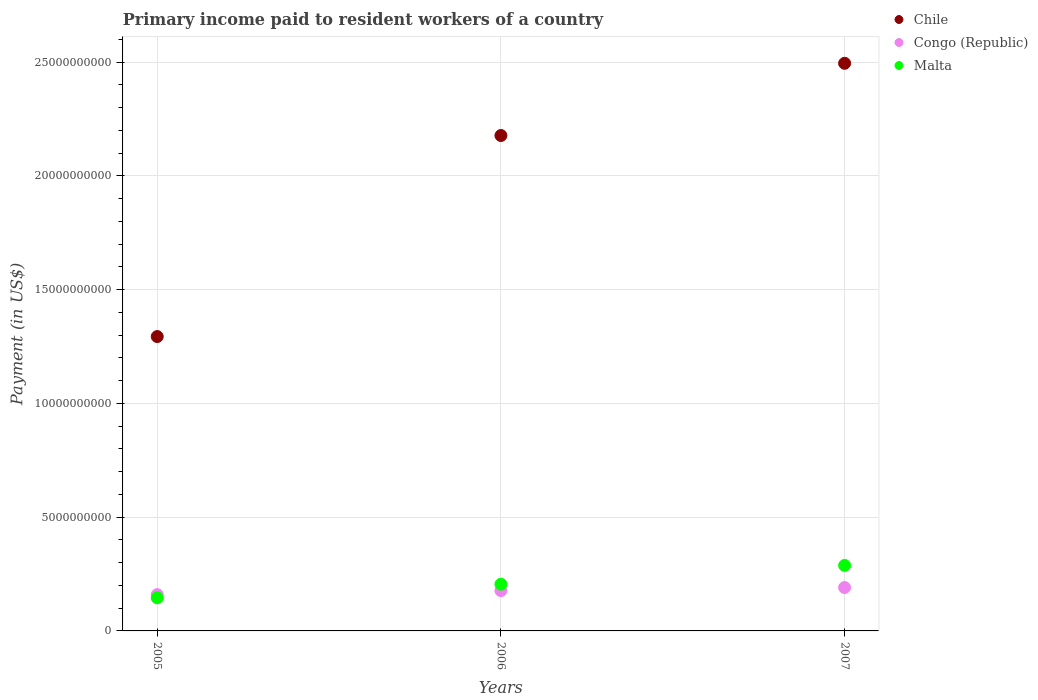Is the number of dotlines equal to the number of legend labels?
Your response must be concise. Yes. What is the amount paid to workers in Congo (Republic) in 2007?
Provide a short and direct response. 1.91e+09. Across all years, what is the maximum amount paid to workers in Malta?
Offer a terse response. 2.88e+09. Across all years, what is the minimum amount paid to workers in Chile?
Offer a terse response. 1.29e+1. In which year was the amount paid to workers in Congo (Republic) maximum?
Offer a terse response. 2007. In which year was the amount paid to workers in Congo (Republic) minimum?
Ensure brevity in your answer.  2005. What is the total amount paid to workers in Congo (Republic) in the graph?
Give a very brief answer. 5.28e+09. What is the difference between the amount paid to workers in Chile in 2006 and that in 2007?
Keep it short and to the point. -3.17e+09. What is the difference between the amount paid to workers in Chile in 2006 and the amount paid to workers in Malta in 2007?
Ensure brevity in your answer.  1.89e+1. What is the average amount paid to workers in Malta per year?
Make the answer very short. 2.13e+09. In the year 2005, what is the difference between the amount paid to workers in Chile and amount paid to workers in Congo (Republic)?
Offer a terse response. 1.13e+1. In how many years, is the amount paid to workers in Chile greater than 2000000000 US$?
Your response must be concise. 3. What is the ratio of the amount paid to workers in Chile in 2005 to that in 2006?
Provide a short and direct response. 0.59. Is the amount paid to workers in Congo (Republic) in 2005 less than that in 2006?
Make the answer very short. Yes. What is the difference between the highest and the second highest amount paid to workers in Chile?
Make the answer very short. 3.17e+09. What is the difference between the highest and the lowest amount paid to workers in Chile?
Ensure brevity in your answer.  1.20e+1. In how many years, is the amount paid to workers in Malta greater than the average amount paid to workers in Malta taken over all years?
Offer a terse response. 1. Is the sum of the amount paid to workers in Congo (Republic) in 2005 and 2006 greater than the maximum amount paid to workers in Chile across all years?
Your answer should be compact. No. Is it the case that in every year, the sum of the amount paid to workers in Chile and amount paid to workers in Malta  is greater than the amount paid to workers in Congo (Republic)?
Provide a short and direct response. Yes. Does the amount paid to workers in Congo (Republic) monotonically increase over the years?
Keep it short and to the point. Yes. Is the amount paid to workers in Chile strictly greater than the amount paid to workers in Congo (Republic) over the years?
Your response must be concise. Yes. How many years are there in the graph?
Your response must be concise. 3. What is the difference between two consecutive major ticks on the Y-axis?
Provide a short and direct response. 5.00e+09. Does the graph contain any zero values?
Offer a terse response. No. Where does the legend appear in the graph?
Provide a succinct answer. Top right. How many legend labels are there?
Your answer should be very brief. 3. What is the title of the graph?
Provide a short and direct response. Primary income paid to resident workers of a country. Does "Ukraine" appear as one of the legend labels in the graph?
Your answer should be compact. No. What is the label or title of the Y-axis?
Keep it short and to the point. Payment (in US$). What is the Payment (in US$) of Chile in 2005?
Provide a succinct answer. 1.29e+1. What is the Payment (in US$) of Congo (Republic) in 2005?
Ensure brevity in your answer.  1.60e+09. What is the Payment (in US$) of Malta in 2005?
Ensure brevity in your answer.  1.45e+09. What is the Payment (in US$) of Chile in 2006?
Provide a short and direct response. 2.18e+1. What is the Payment (in US$) of Congo (Republic) in 2006?
Give a very brief answer. 1.77e+09. What is the Payment (in US$) in Malta in 2006?
Your answer should be very brief. 2.05e+09. What is the Payment (in US$) in Chile in 2007?
Give a very brief answer. 2.49e+1. What is the Payment (in US$) of Congo (Republic) in 2007?
Ensure brevity in your answer.  1.91e+09. What is the Payment (in US$) in Malta in 2007?
Provide a succinct answer. 2.88e+09. Across all years, what is the maximum Payment (in US$) in Chile?
Ensure brevity in your answer.  2.49e+1. Across all years, what is the maximum Payment (in US$) in Congo (Republic)?
Your answer should be very brief. 1.91e+09. Across all years, what is the maximum Payment (in US$) in Malta?
Offer a very short reply. 2.88e+09. Across all years, what is the minimum Payment (in US$) in Chile?
Give a very brief answer. 1.29e+1. Across all years, what is the minimum Payment (in US$) of Congo (Republic)?
Keep it short and to the point. 1.60e+09. Across all years, what is the minimum Payment (in US$) in Malta?
Your response must be concise. 1.45e+09. What is the total Payment (in US$) of Chile in the graph?
Keep it short and to the point. 5.97e+1. What is the total Payment (in US$) of Congo (Republic) in the graph?
Give a very brief answer. 5.28e+09. What is the total Payment (in US$) in Malta in the graph?
Make the answer very short. 6.39e+09. What is the difference between the Payment (in US$) of Chile in 2005 and that in 2006?
Keep it short and to the point. -8.84e+09. What is the difference between the Payment (in US$) in Congo (Republic) in 2005 and that in 2006?
Your answer should be very brief. -1.77e+08. What is the difference between the Payment (in US$) of Malta in 2005 and that in 2006?
Your answer should be compact. -5.99e+08. What is the difference between the Payment (in US$) of Chile in 2005 and that in 2007?
Give a very brief answer. -1.20e+1. What is the difference between the Payment (in US$) of Congo (Republic) in 2005 and that in 2007?
Your response must be concise. -3.13e+08. What is the difference between the Payment (in US$) of Malta in 2005 and that in 2007?
Give a very brief answer. -1.42e+09. What is the difference between the Payment (in US$) of Chile in 2006 and that in 2007?
Your response must be concise. -3.17e+09. What is the difference between the Payment (in US$) in Congo (Republic) in 2006 and that in 2007?
Your answer should be very brief. -1.35e+08. What is the difference between the Payment (in US$) of Malta in 2006 and that in 2007?
Offer a terse response. -8.25e+08. What is the difference between the Payment (in US$) of Chile in 2005 and the Payment (in US$) of Congo (Republic) in 2006?
Offer a very short reply. 1.12e+1. What is the difference between the Payment (in US$) of Chile in 2005 and the Payment (in US$) of Malta in 2006?
Your answer should be compact. 1.09e+1. What is the difference between the Payment (in US$) in Congo (Republic) in 2005 and the Payment (in US$) in Malta in 2006?
Give a very brief answer. -4.58e+08. What is the difference between the Payment (in US$) of Chile in 2005 and the Payment (in US$) of Congo (Republic) in 2007?
Your answer should be very brief. 1.10e+1. What is the difference between the Payment (in US$) of Chile in 2005 and the Payment (in US$) of Malta in 2007?
Keep it short and to the point. 1.01e+1. What is the difference between the Payment (in US$) of Congo (Republic) in 2005 and the Payment (in US$) of Malta in 2007?
Keep it short and to the point. -1.28e+09. What is the difference between the Payment (in US$) in Chile in 2006 and the Payment (in US$) in Congo (Republic) in 2007?
Provide a short and direct response. 1.99e+1. What is the difference between the Payment (in US$) in Chile in 2006 and the Payment (in US$) in Malta in 2007?
Ensure brevity in your answer.  1.89e+1. What is the difference between the Payment (in US$) of Congo (Republic) in 2006 and the Payment (in US$) of Malta in 2007?
Keep it short and to the point. -1.11e+09. What is the average Payment (in US$) in Chile per year?
Offer a terse response. 1.99e+1. What is the average Payment (in US$) in Congo (Republic) per year?
Make the answer very short. 1.76e+09. What is the average Payment (in US$) of Malta per year?
Provide a short and direct response. 2.13e+09. In the year 2005, what is the difference between the Payment (in US$) of Chile and Payment (in US$) of Congo (Republic)?
Offer a very short reply. 1.13e+1. In the year 2005, what is the difference between the Payment (in US$) in Chile and Payment (in US$) in Malta?
Give a very brief answer. 1.15e+1. In the year 2005, what is the difference between the Payment (in US$) in Congo (Republic) and Payment (in US$) in Malta?
Give a very brief answer. 1.41e+08. In the year 2006, what is the difference between the Payment (in US$) of Chile and Payment (in US$) of Congo (Republic)?
Give a very brief answer. 2.00e+1. In the year 2006, what is the difference between the Payment (in US$) in Chile and Payment (in US$) in Malta?
Offer a terse response. 1.97e+1. In the year 2006, what is the difference between the Payment (in US$) of Congo (Republic) and Payment (in US$) of Malta?
Your response must be concise. -2.81e+08. In the year 2007, what is the difference between the Payment (in US$) of Chile and Payment (in US$) of Congo (Republic)?
Offer a very short reply. 2.30e+1. In the year 2007, what is the difference between the Payment (in US$) of Chile and Payment (in US$) of Malta?
Provide a short and direct response. 2.21e+1. In the year 2007, what is the difference between the Payment (in US$) of Congo (Republic) and Payment (in US$) of Malta?
Offer a terse response. -9.71e+08. What is the ratio of the Payment (in US$) in Chile in 2005 to that in 2006?
Your answer should be compact. 0.59. What is the ratio of the Payment (in US$) in Congo (Republic) in 2005 to that in 2006?
Your answer should be very brief. 0.9. What is the ratio of the Payment (in US$) in Malta in 2005 to that in 2006?
Offer a very short reply. 0.71. What is the ratio of the Payment (in US$) in Chile in 2005 to that in 2007?
Your answer should be very brief. 0.52. What is the ratio of the Payment (in US$) in Congo (Republic) in 2005 to that in 2007?
Offer a terse response. 0.84. What is the ratio of the Payment (in US$) in Malta in 2005 to that in 2007?
Your answer should be compact. 0.51. What is the ratio of the Payment (in US$) in Chile in 2006 to that in 2007?
Give a very brief answer. 0.87. What is the ratio of the Payment (in US$) of Congo (Republic) in 2006 to that in 2007?
Offer a terse response. 0.93. What is the ratio of the Payment (in US$) in Malta in 2006 to that in 2007?
Give a very brief answer. 0.71. What is the difference between the highest and the second highest Payment (in US$) of Chile?
Offer a terse response. 3.17e+09. What is the difference between the highest and the second highest Payment (in US$) in Congo (Republic)?
Keep it short and to the point. 1.35e+08. What is the difference between the highest and the second highest Payment (in US$) in Malta?
Provide a short and direct response. 8.25e+08. What is the difference between the highest and the lowest Payment (in US$) in Chile?
Your response must be concise. 1.20e+1. What is the difference between the highest and the lowest Payment (in US$) of Congo (Republic)?
Your response must be concise. 3.13e+08. What is the difference between the highest and the lowest Payment (in US$) of Malta?
Offer a terse response. 1.42e+09. 